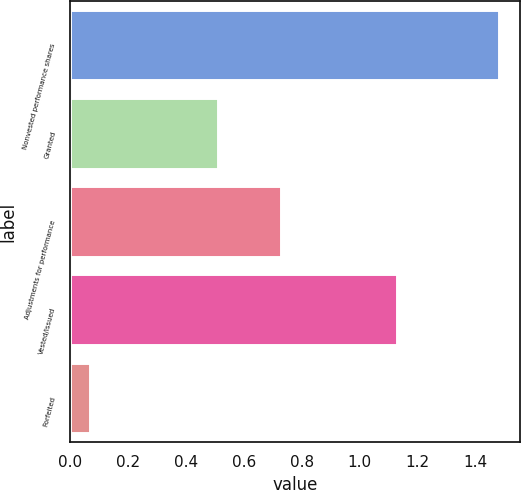Convert chart. <chart><loc_0><loc_0><loc_500><loc_500><bar_chart><fcel>Nonvested performance shares<fcel>Granted<fcel>Adjustments for performance<fcel>Vested/Issued<fcel>Forfeited<nl><fcel>1.48<fcel>0.51<fcel>0.73<fcel>1.13<fcel>0.07<nl></chart> 